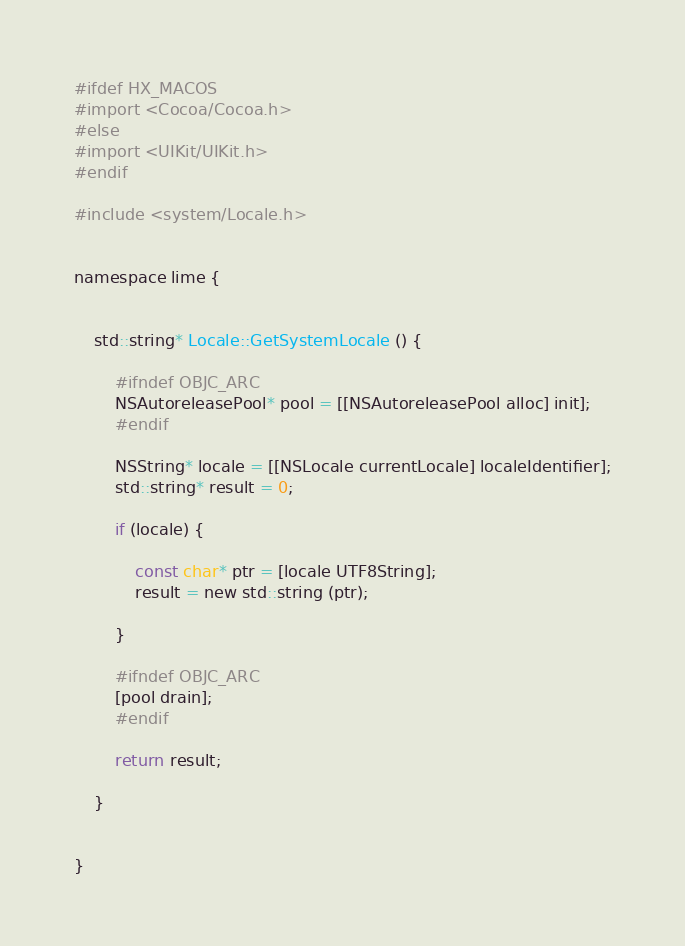<code> <loc_0><loc_0><loc_500><loc_500><_ObjectiveC_>#ifdef HX_MACOS
#import <Cocoa/Cocoa.h>
#else
#import <UIKit/UIKit.h>
#endif

#include <system/Locale.h>


namespace lime {
	
	
	std::string* Locale::GetSystemLocale () {
		
		#ifndef OBJC_ARC
		NSAutoreleasePool* pool = [[NSAutoreleasePool alloc] init];
		#endif
		
		NSString* locale = [[NSLocale currentLocale] localeIdentifier];
		std::string* result = 0;
		
		if (locale) {
			
			const char* ptr = [locale UTF8String];
			result = new std::string (ptr);
			
		}
		
		#ifndef OBJC_ARC
		[pool drain];
		#endif
		
		return result;
		
	}
	
	
}</code> 